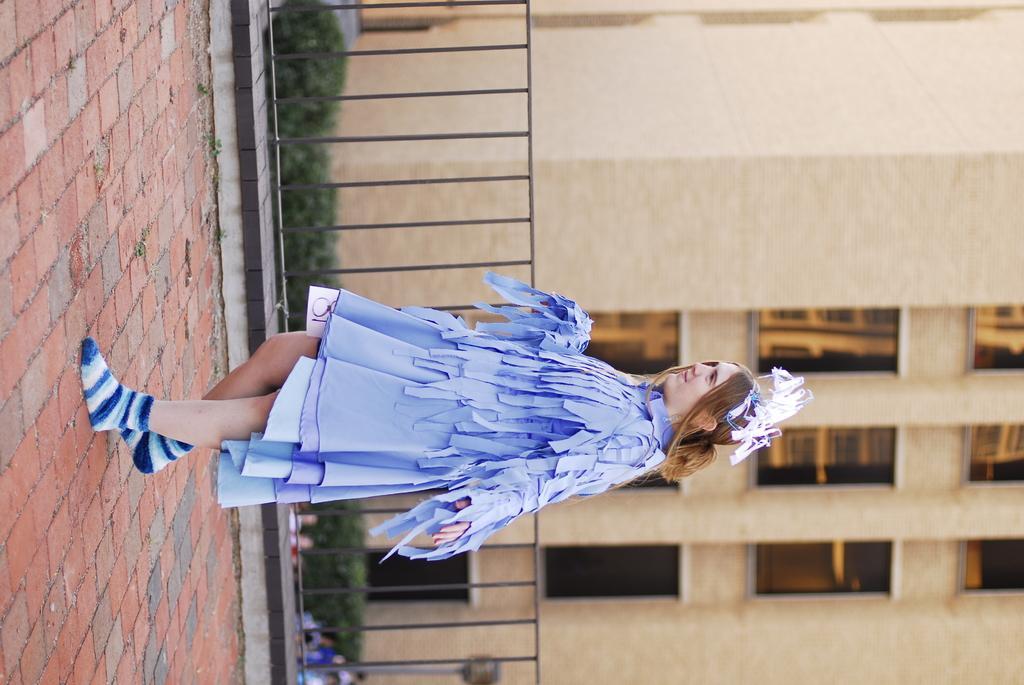In one or two sentences, can you explain what this image depicts? Here we can see a woman. In the background we can see a fence, plants, few persons and a building. 